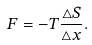<formula> <loc_0><loc_0><loc_500><loc_500>F = - T \frac { \triangle S } { \triangle x } .</formula> 